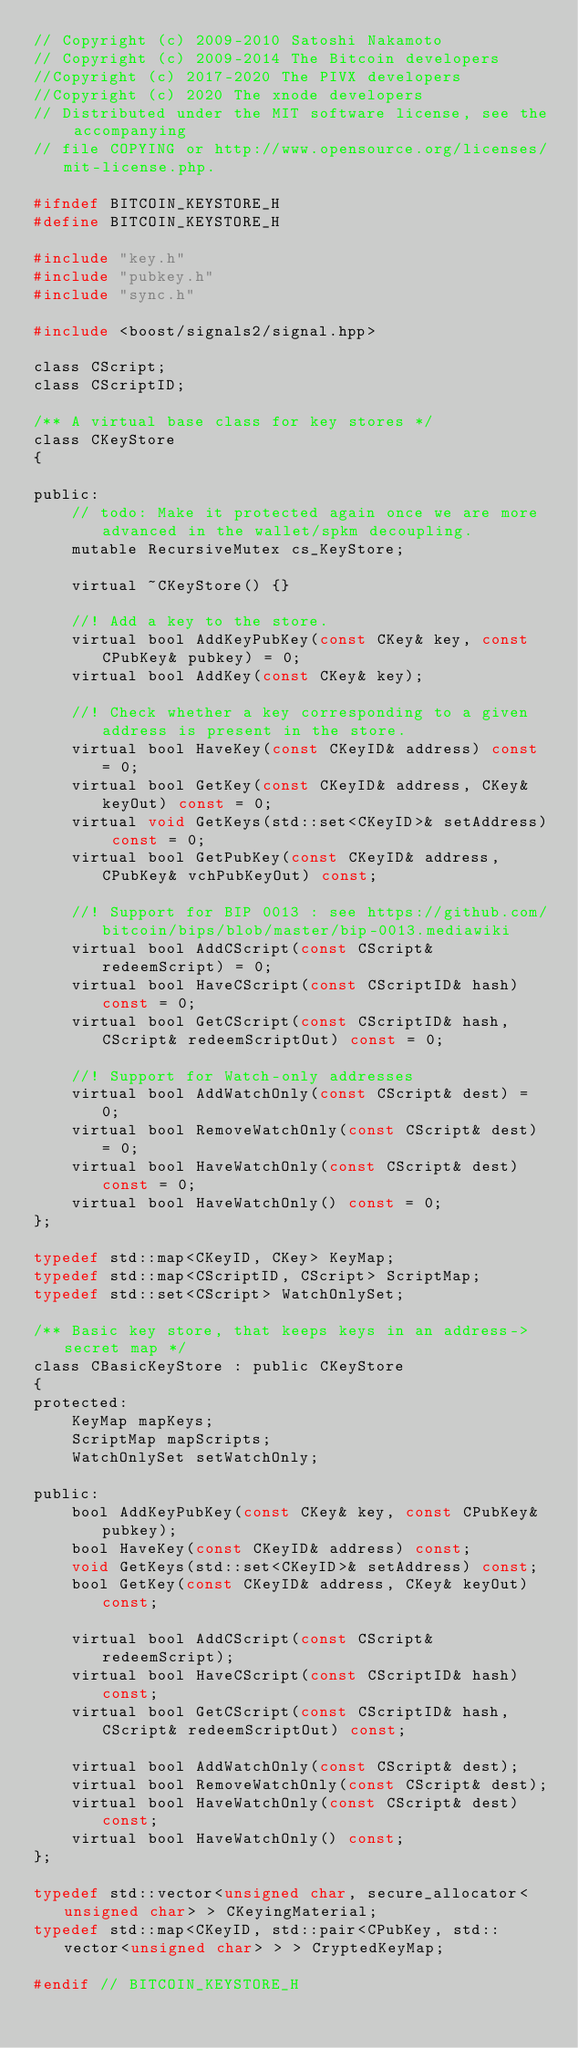<code> <loc_0><loc_0><loc_500><loc_500><_C_>// Copyright (c) 2009-2010 Satoshi Nakamoto
// Copyright (c) 2009-2014 The Bitcoin developers
//Copyright (c) 2017-2020 The PIVX developers
//Copyright (c) 2020 The xnode developers
// Distributed under the MIT software license, see the accompanying
// file COPYING or http://www.opensource.org/licenses/mit-license.php.

#ifndef BITCOIN_KEYSTORE_H
#define BITCOIN_KEYSTORE_H

#include "key.h"
#include "pubkey.h"
#include "sync.h"

#include <boost/signals2/signal.hpp>

class CScript;
class CScriptID;

/** A virtual base class for key stores */
class CKeyStore
{

public:
    // todo: Make it protected again once we are more advanced in the wallet/spkm decoupling.
    mutable RecursiveMutex cs_KeyStore;

    virtual ~CKeyStore() {}

    //! Add a key to the store.
    virtual bool AddKeyPubKey(const CKey& key, const CPubKey& pubkey) = 0;
    virtual bool AddKey(const CKey& key);

    //! Check whether a key corresponding to a given address is present in the store.
    virtual bool HaveKey(const CKeyID& address) const = 0;
    virtual bool GetKey(const CKeyID& address, CKey& keyOut) const = 0;
    virtual void GetKeys(std::set<CKeyID>& setAddress) const = 0;
    virtual bool GetPubKey(const CKeyID& address, CPubKey& vchPubKeyOut) const;

    //! Support for BIP 0013 : see https://github.com/bitcoin/bips/blob/master/bip-0013.mediawiki
    virtual bool AddCScript(const CScript& redeemScript) = 0;
    virtual bool HaveCScript(const CScriptID& hash) const = 0;
    virtual bool GetCScript(const CScriptID& hash, CScript& redeemScriptOut) const = 0;

    //! Support for Watch-only addresses
    virtual bool AddWatchOnly(const CScript& dest) = 0;
    virtual bool RemoveWatchOnly(const CScript& dest) = 0;
    virtual bool HaveWatchOnly(const CScript& dest) const = 0;
    virtual bool HaveWatchOnly() const = 0;
};

typedef std::map<CKeyID, CKey> KeyMap;
typedef std::map<CScriptID, CScript> ScriptMap;
typedef std::set<CScript> WatchOnlySet;

/** Basic key store, that keeps keys in an address->secret map */
class CBasicKeyStore : public CKeyStore
{
protected:
    KeyMap mapKeys;
    ScriptMap mapScripts;
    WatchOnlySet setWatchOnly;

public:
    bool AddKeyPubKey(const CKey& key, const CPubKey& pubkey);
    bool HaveKey(const CKeyID& address) const;
    void GetKeys(std::set<CKeyID>& setAddress) const;
    bool GetKey(const CKeyID& address, CKey& keyOut) const;

    virtual bool AddCScript(const CScript& redeemScript);
    virtual bool HaveCScript(const CScriptID& hash) const;
    virtual bool GetCScript(const CScriptID& hash, CScript& redeemScriptOut) const;

    virtual bool AddWatchOnly(const CScript& dest);
    virtual bool RemoveWatchOnly(const CScript& dest);
    virtual bool HaveWatchOnly(const CScript& dest) const;
    virtual bool HaveWatchOnly() const;
};

typedef std::vector<unsigned char, secure_allocator<unsigned char> > CKeyingMaterial;
typedef std::map<CKeyID, std::pair<CPubKey, std::vector<unsigned char> > > CryptedKeyMap;

#endif // BITCOIN_KEYSTORE_H
</code> 